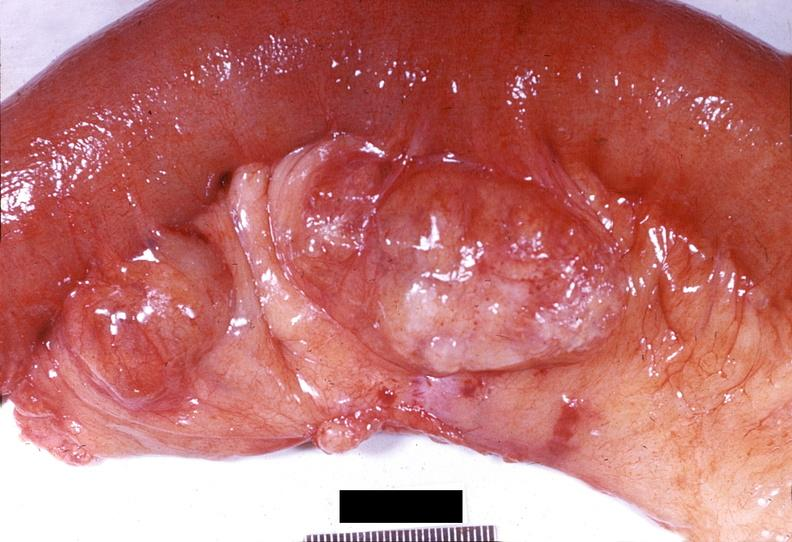s supernumerary digits present?
Answer the question using a single word or phrase. No 